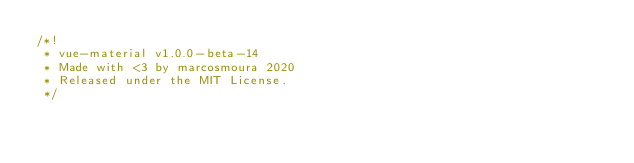Convert code to text. <code><loc_0><loc_0><loc_500><loc_500><_JavaScript_>/*!
 * vue-material v1.0.0-beta-14
 * Made with <3 by marcosmoura 2020
 * Released under the MIT License.
 */</code> 